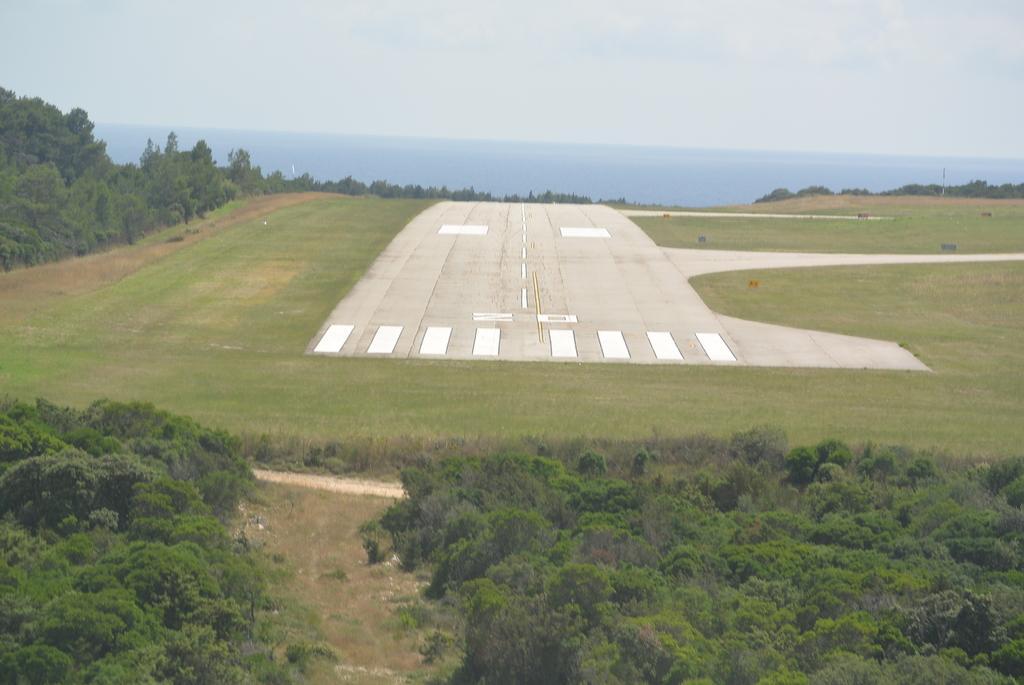Describe this image in one or two sentences. In the image there is a runway in the middle with grassland on either side of it and trees in the front and back and above its sky. 